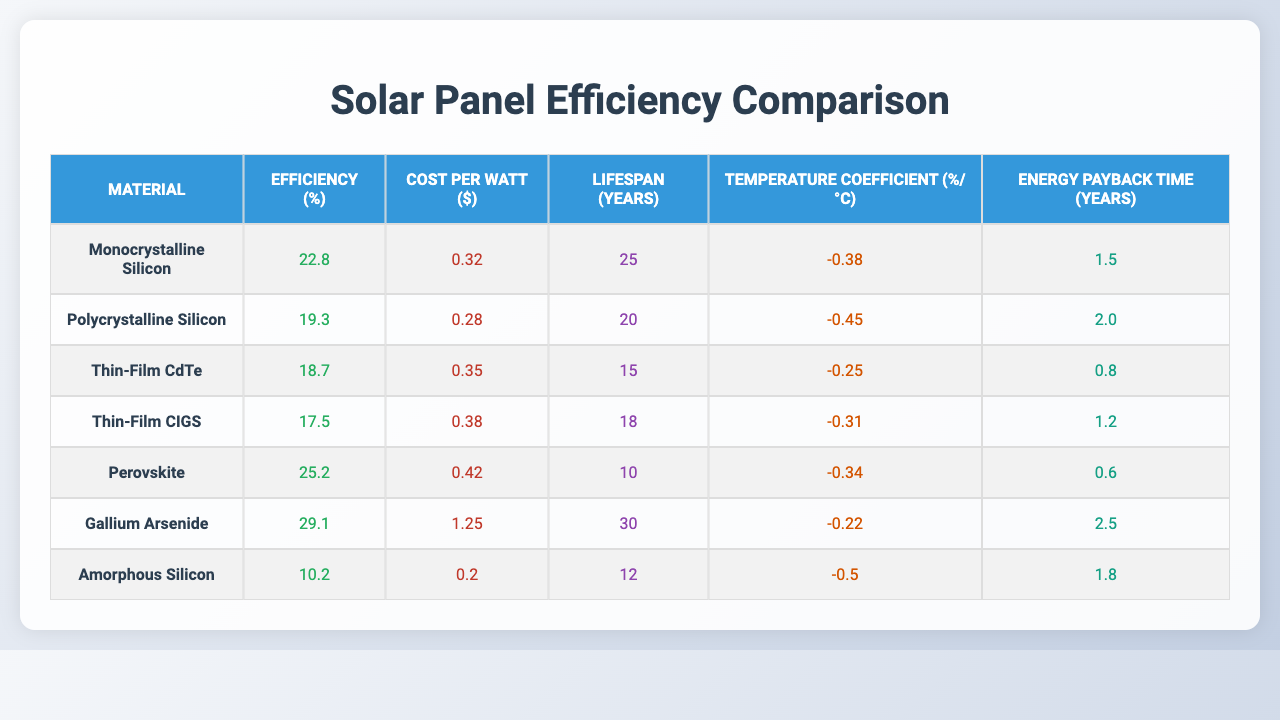What is the efficiency of Gallium Arsenide? The table lists the efficiency of Gallium Arsenide as 29.1%.
Answer: 29.1% Which material has the lowest cost per watt? By comparing the cost per watt values in the table, Amorphous Silicon has the lowest at $0.20.
Answer: $0.20 What is the lifespan of Thin-Film CIGS? The lifespan of Thin-Film CIGS is shown to be 18 years in the table.
Answer: 18 years Is Perovskite more efficient than Polycrystalline Silicon? Perovskite has an efficiency of 25.2%, while Polycrystalline Silicon has 19.3%; therefore, Perovskite is more efficient.
Answer: Yes What is the average efficiency of the materials listed? Efficiency values are (22.8 + 19.3 + 18.7 + 17.5 + 25.2 + 29.1 + 10.2) = 142.8; dividing by 7 gives an average of approximately 20.4%.
Answer: 20.4% Which material has the highest temperature coefficient? Comparing the temperature coefficients in the table, Amorphous Silicon has the highest value at -0.50%.
Answer: -0.50% How much more efficient is Gallium Arsenide compared to Amorphous Silicon? Gallium Arsenide has an efficiency of 29.1% and Amorphous Silicon has 10.2%, so the difference is (29.1 - 10.2) = 18.9%.
Answer: 18.9% Which material has the shortest energy payback time? The shortest energy payback time listed is 0.6 years for Perovskite in the table.
Answer: 0.6 years If we were to combine the efficiencies of Monocrystalline Silicon and Thin-Film CdTe, what would their total be? The efficiencies are 22.8% and 18.7%; summing these gives 22.8 + 18.7 = 41.5%.
Answer: 41.5% True or False: Polycrystalline Silicon has a lifespan greater than 25 years. The table shows Polycrystalline Silicon has a lifespan of 20 years, which is less than 25 years, so the statement is false.
Answer: False 